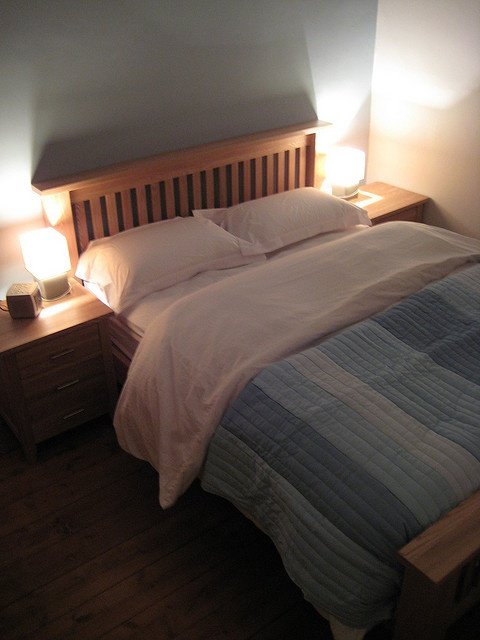Describe the objects in this image and their specific colors. I can see a bed in black, gray, and maroon tones in this image. 